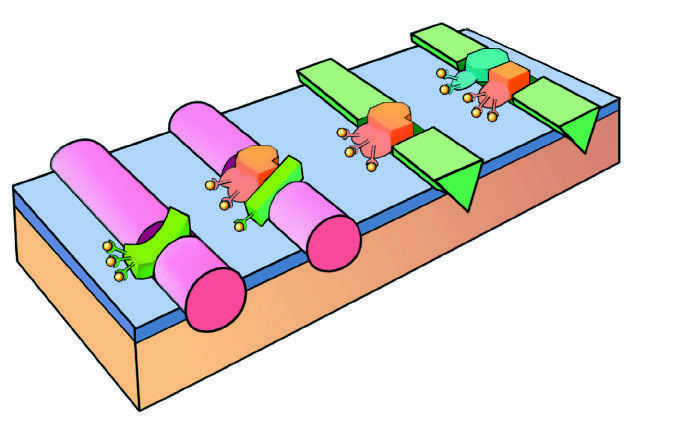what does the initial reaction complex consist of?
Answer the question using a single word or phrase. A protease (factor viia) 